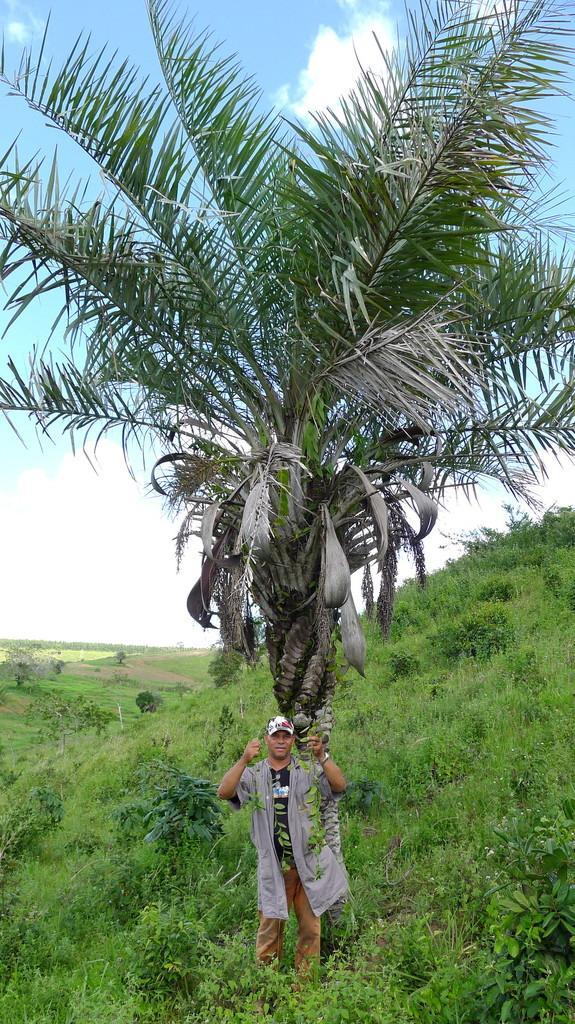Could you give a brief overview of what you see in this image? In the middle of this image, there is a tree having leaves. Beside this tree, there is a person standing on the ground, on which there are plants. In the background, there are trees and grass on the ground and there are clouds in the blue sky. 